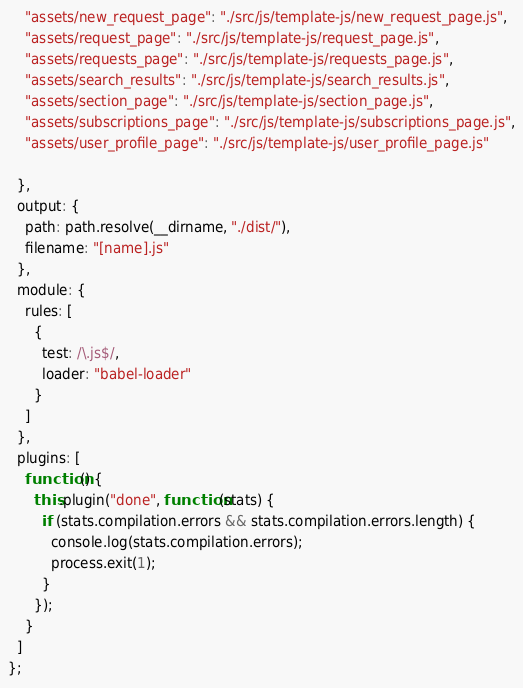Convert code to text. <code><loc_0><loc_0><loc_500><loc_500><_JavaScript_>    "assets/new_request_page": "./src/js/template-js/new_request_page.js",
    "assets/request_page": "./src/js/template-js/request_page.js",
    "assets/requests_page": "./src/js/template-js/requests_page.js",
    "assets/search_results": "./src/js/template-js/search_results.js",
    "assets/section_page": "./src/js/template-js/section_page.js",
    "assets/subscriptions_page": "./src/js/template-js/subscriptions_page.js",
    "assets/user_profile_page": "./src/js/template-js/user_profile_page.js"
  
  },
  output: {
    path: path.resolve(__dirname, "./dist/"),
    filename: "[name].js"
  },
  module: {
    rules: [
      {
        test: /\.js$/,
        loader: "babel-loader"
      }
    ]
  },
  plugins: [
    function() {
      this.plugin("done", function(stats) {
        if (stats.compilation.errors && stats.compilation.errors.length) {
          console.log(stats.compilation.errors);
          process.exit(1);
        }
      });
    }
  ]
};
</code> 